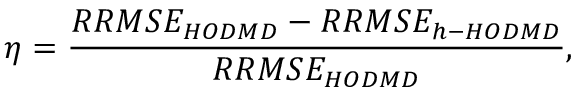<formula> <loc_0><loc_0><loc_500><loc_500>\eta = \frac { R R M S E _ { H O D M D } - R R M S E _ { h - H O D M D } } { R R M S E _ { H O D M D } } ,</formula> 